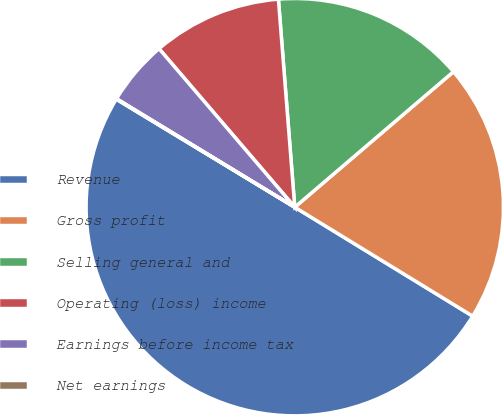<chart> <loc_0><loc_0><loc_500><loc_500><pie_chart><fcel>Revenue<fcel>Gross profit<fcel>Selling general and<fcel>Operating (loss) income<fcel>Earnings before income tax<fcel>Net earnings<nl><fcel>49.91%<fcel>19.99%<fcel>15.0%<fcel>10.02%<fcel>5.03%<fcel>0.04%<nl></chart> 